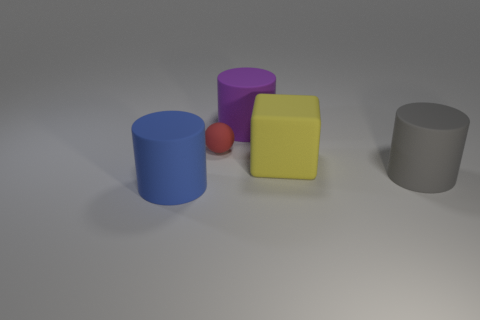Do the shadows give any clue about the light source? The shadows are soft and cast slightly to the front and right of the objects, indicating the light source is behind and to the left of the scene, potentially a single diffuse light similar to an overcast sky or a softbox. 